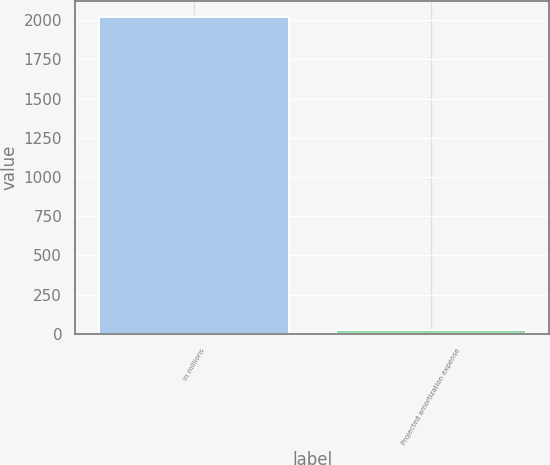Convert chart to OTSL. <chart><loc_0><loc_0><loc_500><loc_500><bar_chart><fcel>In millions<fcel>Projected amortization expense<nl><fcel>2021<fcel>28<nl></chart> 